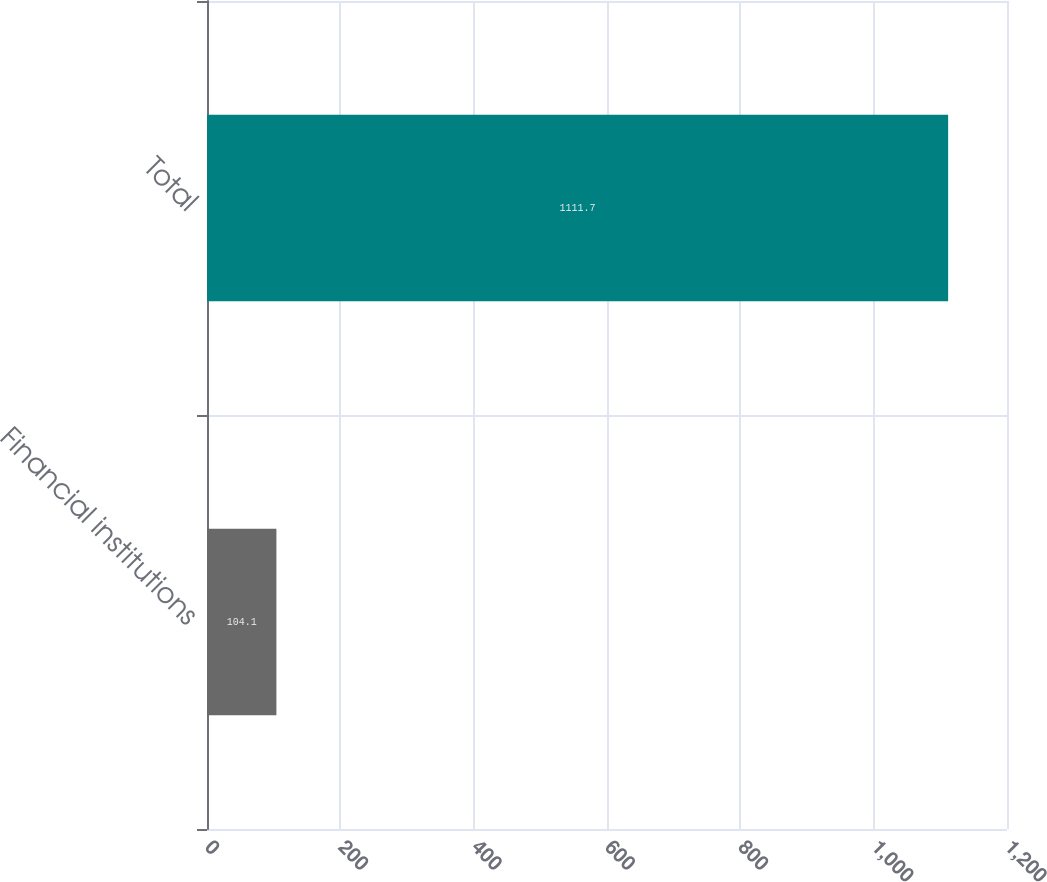Convert chart. <chart><loc_0><loc_0><loc_500><loc_500><bar_chart><fcel>Financial institutions<fcel>Total<nl><fcel>104.1<fcel>1111.7<nl></chart> 